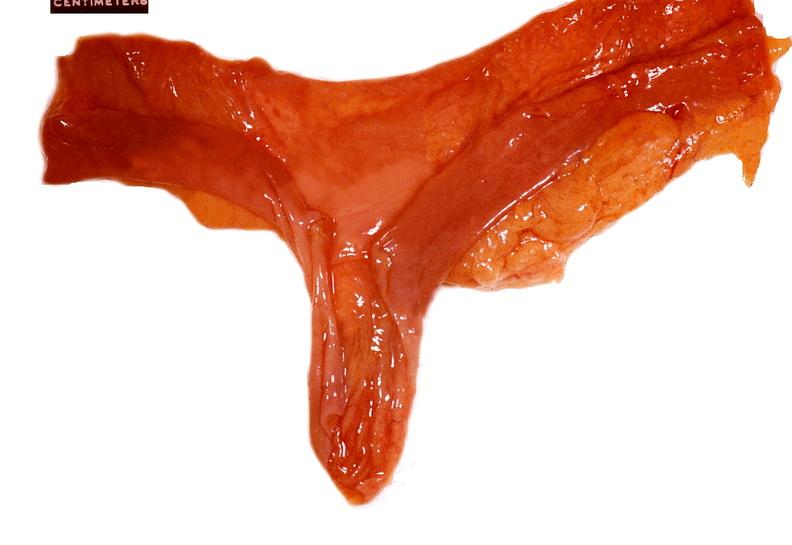what does this image show?
Answer the question using a single word or phrase. Small intestine 